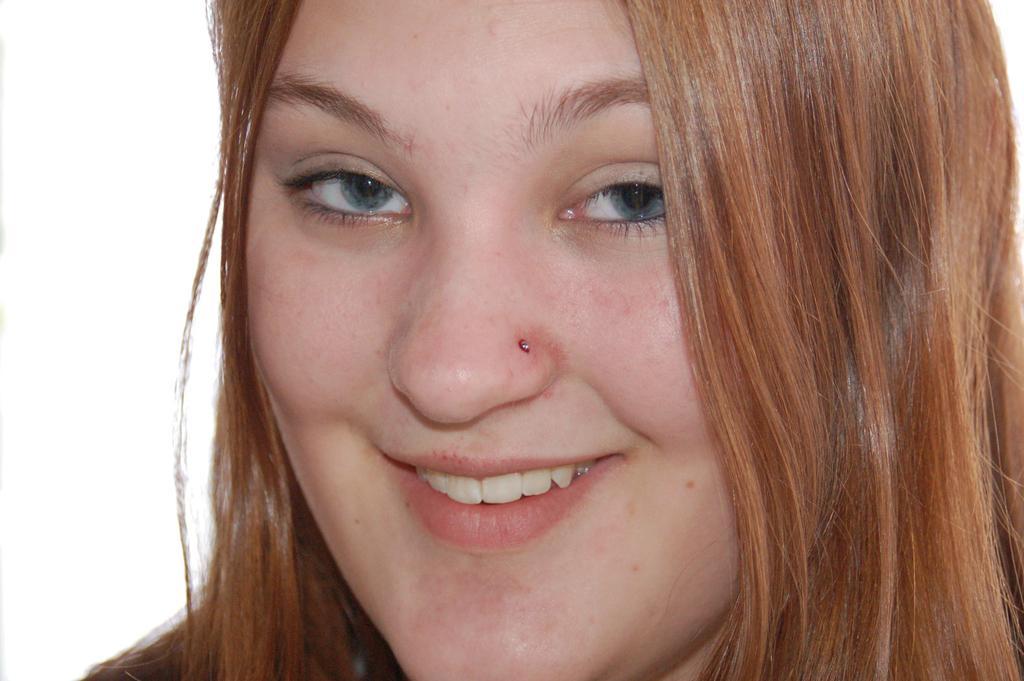Describe this image in one or two sentences. In this image, we can see there is a woman smiling. And the background is white in color. 